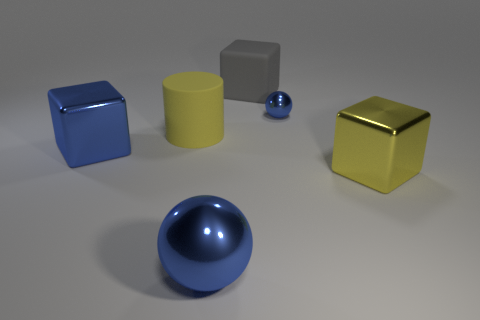There is a big blue shiny sphere; are there any objects in front of it?
Make the answer very short. No. Is the number of blue blocks that are behind the large yellow cylinder greater than the number of large gray blocks on the left side of the large ball?
Provide a succinct answer. No. There is another blue thing that is the same shape as the tiny blue object; what is its size?
Your answer should be compact. Large. What number of cylinders are either blue shiny things or tiny metallic objects?
Your response must be concise. 0. There is a block that is the same color as the matte cylinder; what material is it?
Make the answer very short. Metal. Is the number of big gray matte blocks behind the big blue metal ball less than the number of balls that are behind the big matte cylinder?
Keep it short and to the point. No. What number of things are either blue metallic objects in front of the tiny ball or rubber cylinders?
Provide a succinct answer. 3. There is a yellow object behind the large blue shiny thing that is to the left of the large metal ball; what shape is it?
Provide a succinct answer. Cylinder. Are there any red blocks of the same size as the yellow metal object?
Your answer should be very brief. No. Are there more large red rubber balls than big metal cubes?
Give a very brief answer. No. 